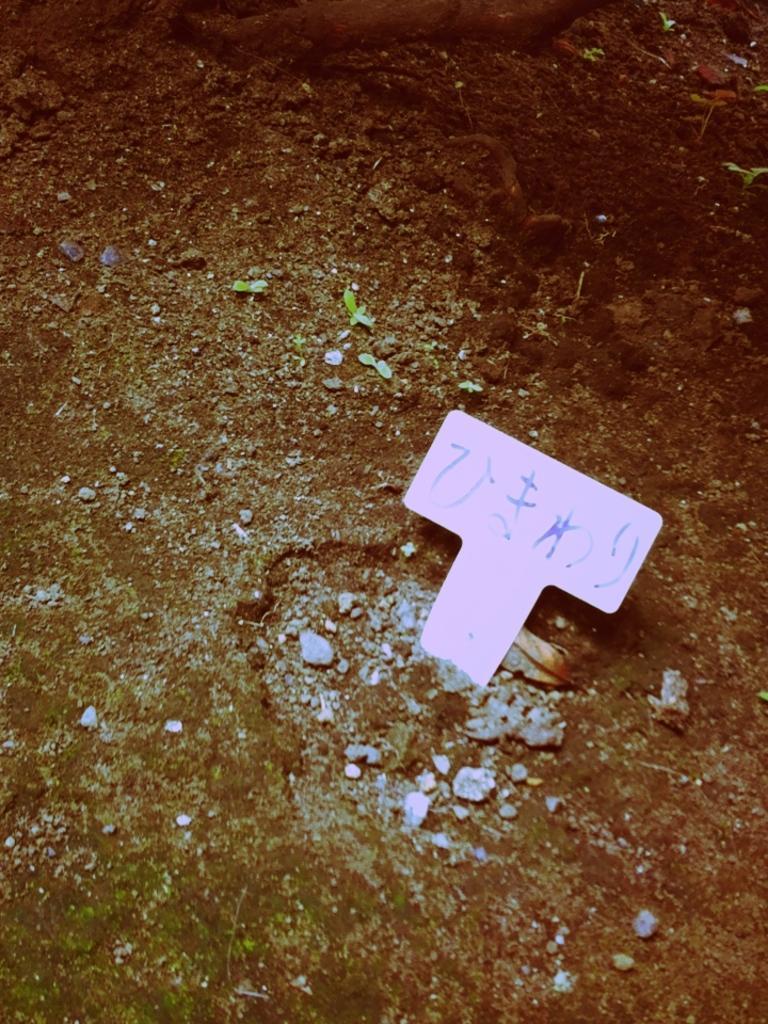Describe this image in one or two sentences. In this image we can see a text written on an object and there are small plants and stones on the ground. 